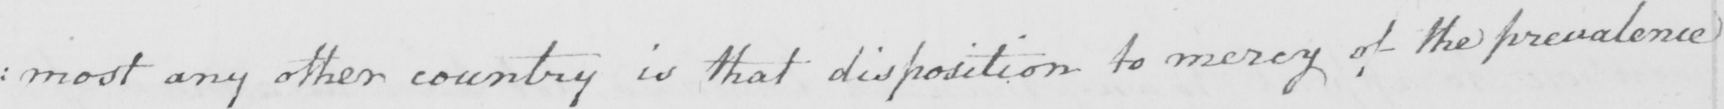What does this handwritten line say? : most any other country is that disposition to mercy of the prevalence 